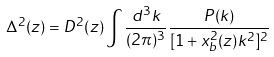Convert formula to latex. <formula><loc_0><loc_0><loc_500><loc_500>\Delta ^ { 2 } ( z ) = D ^ { 2 } ( z ) \int { \frac { d ^ { 3 } k } { ( 2 \pi ) ^ { 3 } } \frac { P ( k ) } { [ 1 + x _ { b } ^ { 2 } ( z ) k ^ { 2 } ] ^ { 2 } } }</formula> 